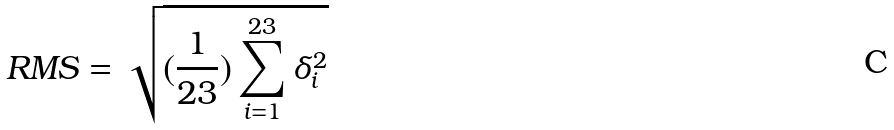Convert formula to latex. <formula><loc_0><loc_0><loc_500><loc_500>R M S = \sqrt { ( \frac { 1 } { 2 3 } ) \sum _ { i = 1 } ^ { 2 3 } \delta _ { i } ^ { 2 } }</formula> 